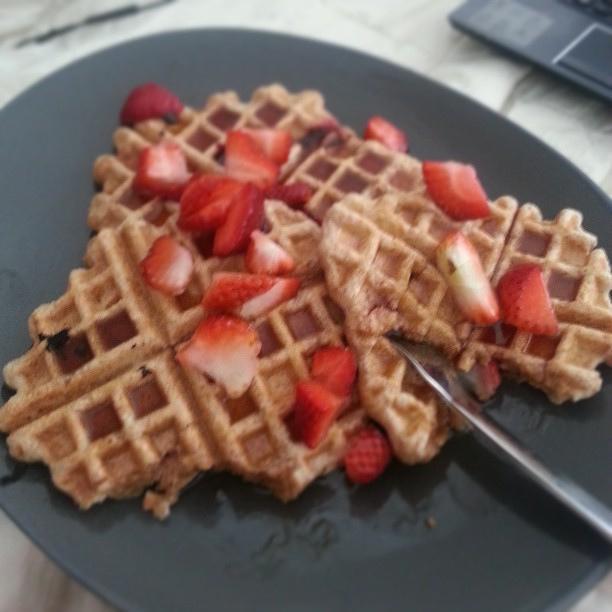What is most likely to be added to this food item?
Choose the right answer from the provided options to respond to the question.
Options: Apples, syrup, milk, jam. Syrup. 